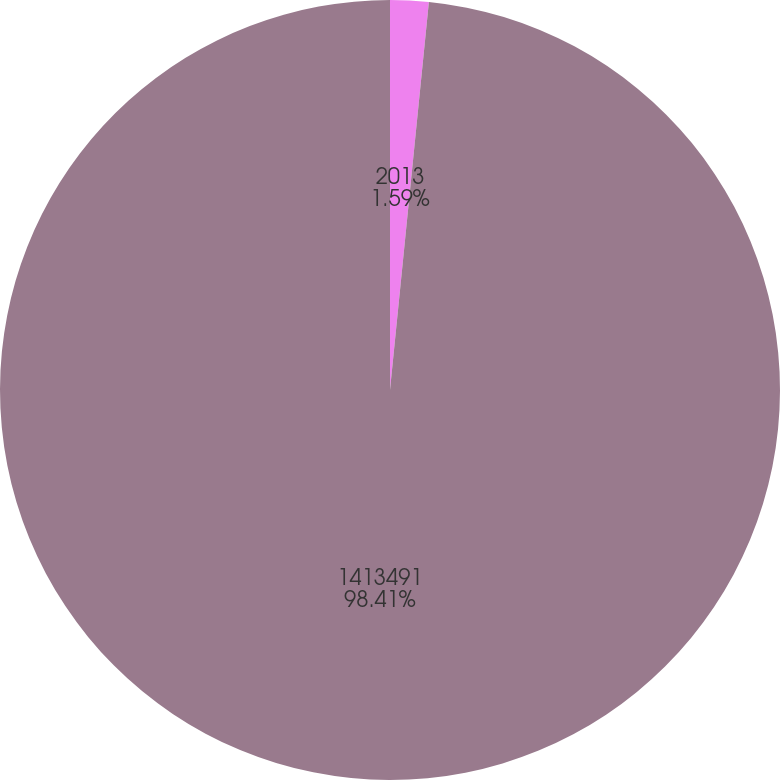<chart> <loc_0><loc_0><loc_500><loc_500><pie_chart><fcel>2013<fcel>1413491<nl><fcel>1.59%<fcel>98.41%<nl></chart> 